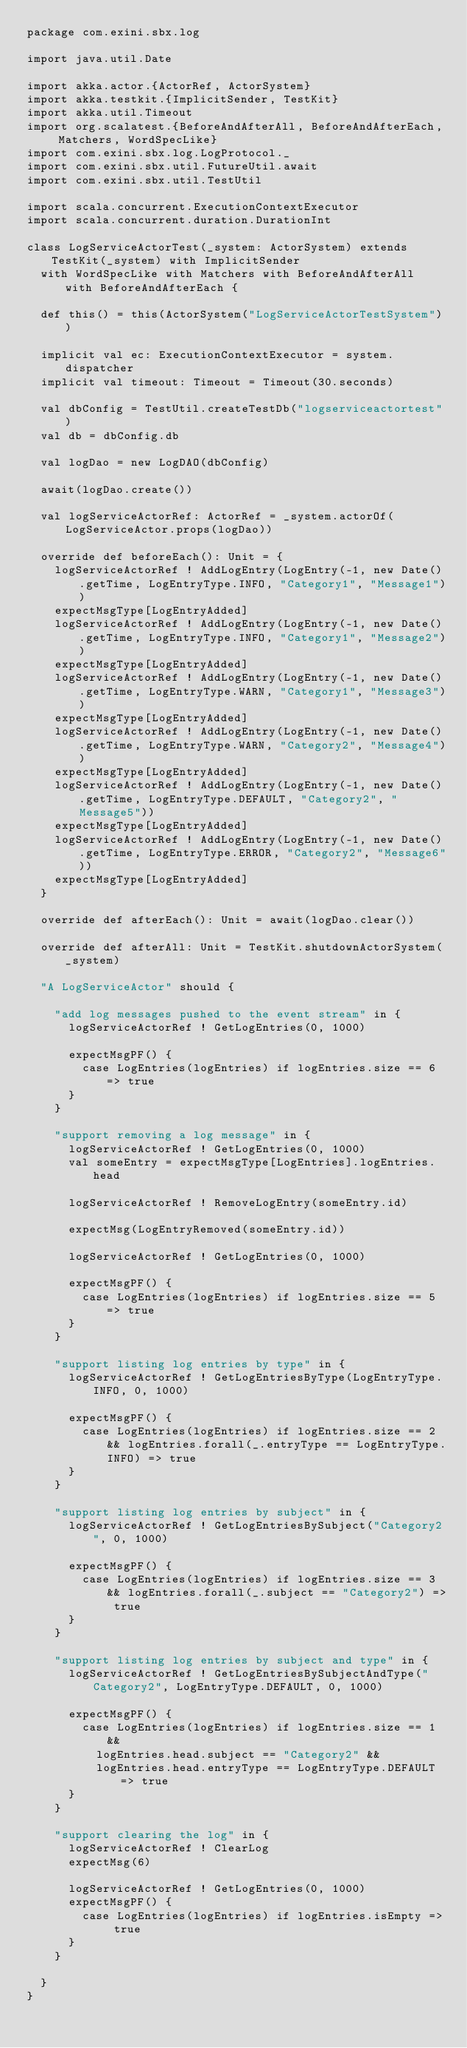<code> <loc_0><loc_0><loc_500><loc_500><_Scala_>package com.exini.sbx.log

import java.util.Date

import akka.actor.{ActorRef, ActorSystem}
import akka.testkit.{ImplicitSender, TestKit}
import akka.util.Timeout
import org.scalatest.{BeforeAndAfterAll, BeforeAndAfterEach, Matchers, WordSpecLike}
import com.exini.sbx.log.LogProtocol._
import com.exini.sbx.util.FutureUtil.await
import com.exini.sbx.util.TestUtil

import scala.concurrent.ExecutionContextExecutor
import scala.concurrent.duration.DurationInt

class LogServiceActorTest(_system: ActorSystem) extends TestKit(_system) with ImplicitSender
  with WordSpecLike with Matchers with BeforeAndAfterAll with BeforeAndAfterEach {

  def this() = this(ActorSystem("LogServiceActorTestSystem"))

  implicit val ec: ExecutionContextExecutor = system.dispatcher
  implicit val timeout: Timeout = Timeout(30.seconds)

  val dbConfig = TestUtil.createTestDb("logserviceactortest")
  val db = dbConfig.db

  val logDao = new LogDAO(dbConfig)

  await(logDao.create())

  val logServiceActorRef: ActorRef = _system.actorOf(LogServiceActor.props(logDao))

  override def beforeEach(): Unit = {
    logServiceActorRef ! AddLogEntry(LogEntry(-1, new Date().getTime, LogEntryType.INFO, "Category1", "Message1"))
    expectMsgType[LogEntryAdded]
    logServiceActorRef ! AddLogEntry(LogEntry(-1, new Date().getTime, LogEntryType.INFO, "Category1", "Message2"))
    expectMsgType[LogEntryAdded]
    logServiceActorRef ! AddLogEntry(LogEntry(-1, new Date().getTime, LogEntryType.WARN, "Category1", "Message3"))
    expectMsgType[LogEntryAdded]
    logServiceActorRef ! AddLogEntry(LogEntry(-1, new Date().getTime, LogEntryType.WARN, "Category2", "Message4"))
    expectMsgType[LogEntryAdded]
    logServiceActorRef ! AddLogEntry(LogEntry(-1, new Date().getTime, LogEntryType.DEFAULT, "Category2", "Message5"))
    expectMsgType[LogEntryAdded]
    logServiceActorRef ! AddLogEntry(LogEntry(-1, new Date().getTime, LogEntryType.ERROR, "Category2", "Message6"))
    expectMsgType[LogEntryAdded]
  }

  override def afterEach(): Unit = await(logDao.clear())

  override def afterAll: Unit = TestKit.shutdownActorSystem(_system)

  "A LogServiceActor" should {

    "add log messages pushed to the event stream" in {
      logServiceActorRef ! GetLogEntries(0, 1000)

      expectMsgPF() {
        case LogEntries(logEntries) if logEntries.size == 6 => true
      }
    }

    "support removing a log message" in {
      logServiceActorRef ! GetLogEntries(0, 1000)
      val someEntry = expectMsgType[LogEntries].logEntries.head

      logServiceActorRef ! RemoveLogEntry(someEntry.id)

      expectMsg(LogEntryRemoved(someEntry.id))

      logServiceActorRef ! GetLogEntries(0, 1000)

      expectMsgPF() {
        case LogEntries(logEntries) if logEntries.size == 5 => true
      }
    }

    "support listing log entries by type" in {
      logServiceActorRef ! GetLogEntriesByType(LogEntryType.INFO, 0, 1000)

      expectMsgPF() {
        case LogEntries(logEntries) if logEntries.size == 2 && logEntries.forall(_.entryType == LogEntryType.INFO) => true
      }
    }

    "support listing log entries by subject" in {
      logServiceActorRef ! GetLogEntriesBySubject("Category2", 0, 1000)

      expectMsgPF() {
        case LogEntries(logEntries) if logEntries.size == 3 && logEntries.forall(_.subject == "Category2") => true
      }
    }

    "support listing log entries by subject and type" in {
      logServiceActorRef ! GetLogEntriesBySubjectAndType("Category2", LogEntryType.DEFAULT, 0, 1000)

      expectMsgPF() {
        case LogEntries(logEntries) if logEntries.size == 1 &&
          logEntries.head.subject == "Category2" &&
          logEntries.head.entryType == LogEntryType.DEFAULT => true
      }
    }

    "support clearing the log" in {
      logServiceActorRef ! ClearLog
      expectMsg(6)

      logServiceActorRef ! GetLogEntries(0, 1000)
      expectMsgPF() {
        case LogEntries(logEntries) if logEntries.isEmpty => true
      }
    }

  }
}</code> 